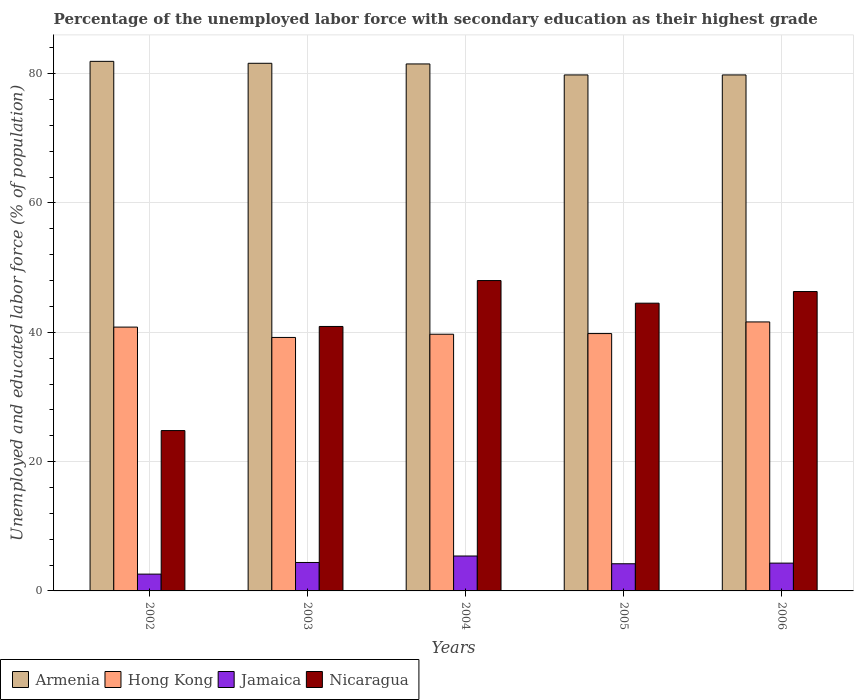Are the number of bars on each tick of the X-axis equal?
Your answer should be compact. Yes. How many bars are there on the 2nd tick from the right?
Provide a succinct answer. 4. What is the label of the 3rd group of bars from the left?
Keep it short and to the point. 2004. In how many cases, is the number of bars for a given year not equal to the number of legend labels?
Your answer should be very brief. 0. What is the percentage of the unemployed labor force with secondary education in Jamaica in 2006?
Your response must be concise. 4.3. Across all years, what is the minimum percentage of the unemployed labor force with secondary education in Hong Kong?
Your answer should be very brief. 39.2. In which year was the percentage of the unemployed labor force with secondary education in Armenia minimum?
Provide a succinct answer. 2005. What is the total percentage of the unemployed labor force with secondary education in Jamaica in the graph?
Make the answer very short. 20.9. What is the difference between the percentage of the unemployed labor force with secondary education in Hong Kong in 2003 and that in 2006?
Make the answer very short. -2.4. What is the difference between the percentage of the unemployed labor force with secondary education in Hong Kong in 2003 and the percentage of the unemployed labor force with secondary education in Armenia in 2004?
Provide a succinct answer. -42.3. What is the average percentage of the unemployed labor force with secondary education in Armenia per year?
Your answer should be very brief. 80.92. In the year 2006, what is the difference between the percentage of the unemployed labor force with secondary education in Armenia and percentage of the unemployed labor force with secondary education in Hong Kong?
Your answer should be compact. 38.2. What is the ratio of the percentage of the unemployed labor force with secondary education in Hong Kong in 2002 to that in 2006?
Give a very brief answer. 0.98. Is the difference between the percentage of the unemployed labor force with secondary education in Armenia in 2004 and 2005 greater than the difference between the percentage of the unemployed labor force with secondary education in Hong Kong in 2004 and 2005?
Offer a terse response. Yes. What is the difference between the highest and the second highest percentage of the unemployed labor force with secondary education in Nicaragua?
Keep it short and to the point. 1.7. What is the difference between the highest and the lowest percentage of the unemployed labor force with secondary education in Hong Kong?
Your answer should be very brief. 2.4. In how many years, is the percentage of the unemployed labor force with secondary education in Armenia greater than the average percentage of the unemployed labor force with secondary education in Armenia taken over all years?
Ensure brevity in your answer.  3. Is the sum of the percentage of the unemployed labor force with secondary education in Armenia in 2002 and 2004 greater than the maximum percentage of the unemployed labor force with secondary education in Hong Kong across all years?
Make the answer very short. Yes. What does the 1st bar from the left in 2003 represents?
Provide a short and direct response. Armenia. What does the 3rd bar from the right in 2002 represents?
Keep it short and to the point. Hong Kong. Is it the case that in every year, the sum of the percentage of the unemployed labor force with secondary education in Armenia and percentage of the unemployed labor force with secondary education in Jamaica is greater than the percentage of the unemployed labor force with secondary education in Hong Kong?
Offer a terse response. Yes. How many bars are there?
Offer a very short reply. 20. How many years are there in the graph?
Give a very brief answer. 5. What is the difference between two consecutive major ticks on the Y-axis?
Offer a very short reply. 20. Does the graph contain any zero values?
Make the answer very short. No. Does the graph contain grids?
Give a very brief answer. Yes. What is the title of the graph?
Provide a succinct answer. Percentage of the unemployed labor force with secondary education as their highest grade. What is the label or title of the X-axis?
Provide a short and direct response. Years. What is the label or title of the Y-axis?
Offer a terse response. Unemployed and educated labor force (% of population). What is the Unemployed and educated labor force (% of population) of Armenia in 2002?
Your response must be concise. 81.9. What is the Unemployed and educated labor force (% of population) in Hong Kong in 2002?
Provide a short and direct response. 40.8. What is the Unemployed and educated labor force (% of population) of Jamaica in 2002?
Your answer should be compact. 2.6. What is the Unemployed and educated labor force (% of population) in Nicaragua in 2002?
Provide a succinct answer. 24.8. What is the Unemployed and educated labor force (% of population) of Armenia in 2003?
Offer a very short reply. 81.6. What is the Unemployed and educated labor force (% of population) of Hong Kong in 2003?
Provide a succinct answer. 39.2. What is the Unemployed and educated labor force (% of population) in Jamaica in 2003?
Offer a very short reply. 4.4. What is the Unemployed and educated labor force (% of population) in Nicaragua in 2003?
Keep it short and to the point. 40.9. What is the Unemployed and educated labor force (% of population) in Armenia in 2004?
Keep it short and to the point. 81.5. What is the Unemployed and educated labor force (% of population) in Hong Kong in 2004?
Provide a short and direct response. 39.7. What is the Unemployed and educated labor force (% of population) of Jamaica in 2004?
Provide a succinct answer. 5.4. What is the Unemployed and educated labor force (% of population) of Nicaragua in 2004?
Offer a very short reply. 48. What is the Unemployed and educated labor force (% of population) in Armenia in 2005?
Keep it short and to the point. 79.8. What is the Unemployed and educated labor force (% of population) in Hong Kong in 2005?
Ensure brevity in your answer.  39.8. What is the Unemployed and educated labor force (% of population) in Jamaica in 2005?
Your answer should be very brief. 4.2. What is the Unemployed and educated labor force (% of population) of Nicaragua in 2005?
Offer a terse response. 44.5. What is the Unemployed and educated labor force (% of population) in Armenia in 2006?
Make the answer very short. 79.8. What is the Unemployed and educated labor force (% of population) in Hong Kong in 2006?
Ensure brevity in your answer.  41.6. What is the Unemployed and educated labor force (% of population) of Jamaica in 2006?
Give a very brief answer. 4.3. What is the Unemployed and educated labor force (% of population) of Nicaragua in 2006?
Provide a short and direct response. 46.3. Across all years, what is the maximum Unemployed and educated labor force (% of population) of Armenia?
Ensure brevity in your answer.  81.9. Across all years, what is the maximum Unemployed and educated labor force (% of population) in Hong Kong?
Make the answer very short. 41.6. Across all years, what is the maximum Unemployed and educated labor force (% of population) of Jamaica?
Keep it short and to the point. 5.4. Across all years, what is the minimum Unemployed and educated labor force (% of population) in Armenia?
Offer a terse response. 79.8. Across all years, what is the minimum Unemployed and educated labor force (% of population) of Hong Kong?
Offer a very short reply. 39.2. Across all years, what is the minimum Unemployed and educated labor force (% of population) of Jamaica?
Your answer should be very brief. 2.6. Across all years, what is the minimum Unemployed and educated labor force (% of population) in Nicaragua?
Provide a short and direct response. 24.8. What is the total Unemployed and educated labor force (% of population) of Armenia in the graph?
Offer a very short reply. 404.6. What is the total Unemployed and educated labor force (% of population) of Hong Kong in the graph?
Ensure brevity in your answer.  201.1. What is the total Unemployed and educated labor force (% of population) of Jamaica in the graph?
Provide a succinct answer. 20.9. What is the total Unemployed and educated labor force (% of population) in Nicaragua in the graph?
Your response must be concise. 204.5. What is the difference between the Unemployed and educated labor force (% of population) in Armenia in 2002 and that in 2003?
Offer a very short reply. 0.3. What is the difference between the Unemployed and educated labor force (% of population) of Nicaragua in 2002 and that in 2003?
Make the answer very short. -16.1. What is the difference between the Unemployed and educated labor force (% of population) of Jamaica in 2002 and that in 2004?
Offer a very short reply. -2.8. What is the difference between the Unemployed and educated labor force (% of population) of Nicaragua in 2002 and that in 2004?
Keep it short and to the point. -23.2. What is the difference between the Unemployed and educated labor force (% of population) of Armenia in 2002 and that in 2005?
Your answer should be very brief. 2.1. What is the difference between the Unemployed and educated labor force (% of population) in Hong Kong in 2002 and that in 2005?
Your response must be concise. 1. What is the difference between the Unemployed and educated labor force (% of population) in Nicaragua in 2002 and that in 2005?
Provide a short and direct response. -19.7. What is the difference between the Unemployed and educated labor force (% of population) in Hong Kong in 2002 and that in 2006?
Provide a succinct answer. -0.8. What is the difference between the Unemployed and educated labor force (% of population) of Nicaragua in 2002 and that in 2006?
Provide a succinct answer. -21.5. What is the difference between the Unemployed and educated labor force (% of population) of Hong Kong in 2003 and that in 2004?
Keep it short and to the point. -0.5. What is the difference between the Unemployed and educated labor force (% of population) in Nicaragua in 2003 and that in 2004?
Make the answer very short. -7.1. What is the difference between the Unemployed and educated labor force (% of population) of Armenia in 2003 and that in 2005?
Give a very brief answer. 1.8. What is the difference between the Unemployed and educated labor force (% of population) in Hong Kong in 2003 and that in 2005?
Offer a very short reply. -0.6. What is the difference between the Unemployed and educated labor force (% of population) in Jamaica in 2003 and that in 2005?
Make the answer very short. 0.2. What is the difference between the Unemployed and educated labor force (% of population) of Nicaragua in 2003 and that in 2005?
Ensure brevity in your answer.  -3.6. What is the difference between the Unemployed and educated labor force (% of population) in Armenia in 2003 and that in 2006?
Your answer should be compact. 1.8. What is the difference between the Unemployed and educated labor force (% of population) in Jamaica in 2003 and that in 2006?
Make the answer very short. 0.1. What is the difference between the Unemployed and educated labor force (% of population) in Nicaragua in 2003 and that in 2006?
Provide a succinct answer. -5.4. What is the difference between the Unemployed and educated labor force (% of population) of Armenia in 2004 and that in 2005?
Keep it short and to the point. 1.7. What is the difference between the Unemployed and educated labor force (% of population) of Jamaica in 2004 and that in 2005?
Your answer should be very brief. 1.2. What is the difference between the Unemployed and educated labor force (% of population) in Nicaragua in 2004 and that in 2005?
Give a very brief answer. 3.5. What is the difference between the Unemployed and educated labor force (% of population) in Hong Kong in 2004 and that in 2006?
Your response must be concise. -1.9. What is the difference between the Unemployed and educated labor force (% of population) in Armenia in 2005 and that in 2006?
Your answer should be compact. 0. What is the difference between the Unemployed and educated labor force (% of population) of Hong Kong in 2005 and that in 2006?
Offer a very short reply. -1.8. What is the difference between the Unemployed and educated labor force (% of population) in Jamaica in 2005 and that in 2006?
Provide a succinct answer. -0.1. What is the difference between the Unemployed and educated labor force (% of population) of Armenia in 2002 and the Unemployed and educated labor force (% of population) of Hong Kong in 2003?
Your answer should be compact. 42.7. What is the difference between the Unemployed and educated labor force (% of population) of Armenia in 2002 and the Unemployed and educated labor force (% of population) of Jamaica in 2003?
Keep it short and to the point. 77.5. What is the difference between the Unemployed and educated labor force (% of population) in Armenia in 2002 and the Unemployed and educated labor force (% of population) in Nicaragua in 2003?
Provide a succinct answer. 41. What is the difference between the Unemployed and educated labor force (% of population) of Hong Kong in 2002 and the Unemployed and educated labor force (% of population) of Jamaica in 2003?
Provide a succinct answer. 36.4. What is the difference between the Unemployed and educated labor force (% of population) of Hong Kong in 2002 and the Unemployed and educated labor force (% of population) of Nicaragua in 2003?
Your answer should be compact. -0.1. What is the difference between the Unemployed and educated labor force (% of population) of Jamaica in 2002 and the Unemployed and educated labor force (% of population) of Nicaragua in 2003?
Keep it short and to the point. -38.3. What is the difference between the Unemployed and educated labor force (% of population) of Armenia in 2002 and the Unemployed and educated labor force (% of population) of Hong Kong in 2004?
Provide a short and direct response. 42.2. What is the difference between the Unemployed and educated labor force (% of population) of Armenia in 2002 and the Unemployed and educated labor force (% of population) of Jamaica in 2004?
Provide a short and direct response. 76.5. What is the difference between the Unemployed and educated labor force (% of population) of Armenia in 2002 and the Unemployed and educated labor force (% of population) of Nicaragua in 2004?
Your response must be concise. 33.9. What is the difference between the Unemployed and educated labor force (% of population) in Hong Kong in 2002 and the Unemployed and educated labor force (% of population) in Jamaica in 2004?
Your answer should be very brief. 35.4. What is the difference between the Unemployed and educated labor force (% of population) of Hong Kong in 2002 and the Unemployed and educated labor force (% of population) of Nicaragua in 2004?
Your answer should be compact. -7.2. What is the difference between the Unemployed and educated labor force (% of population) in Jamaica in 2002 and the Unemployed and educated labor force (% of population) in Nicaragua in 2004?
Your response must be concise. -45.4. What is the difference between the Unemployed and educated labor force (% of population) in Armenia in 2002 and the Unemployed and educated labor force (% of population) in Hong Kong in 2005?
Ensure brevity in your answer.  42.1. What is the difference between the Unemployed and educated labor force (% of population) in Armenia in 2002 and the Unemployed and educated labor force (% of population) in Jamaica in 2005?
Make the answer very short. 77.7. What is the difference between the Unemployed and educated labor force (% of population) of Armenia in 2002 and the Unemployed and educated labor force (% of population) of Nicaragua in 2005?
Ensure brevity in your answer.  37.4. What is the difference between the Unemployed and educated labor force (% of population) in Hong Kong in 2002 and the Unemployed and educated labor force (% of population) in Jamaica in 2005?
Your response must be concise. 36.6. What is the difference between the Unemployed and educated labor force (% of population) in Hong Kong in 2002 and the Unemployed and educated labor force (% of population) in Nicaragua in 2005?
Offer a very short reply. -3.7. What is the difference between the Unemployed and educated labor force (% of population) in Jamaica in 2002 and the Unemployed and educated labor force (% of population) in Nicaragua in 2005?
Provide a succinct answer. -41.9. What is the difference between the Unemployed and educated labor force (% of population) in Armenia in 2002 and the Unemployed and educated labor force (% of population) in Hong Kong in 2006?
Ensure brevity in your answer.  40.3. What is the difference between the Unemployed and educated labor force (% of population) in Armenia in 2002 and the Unemployed and educated labor force (% of population) in Jamaica in 2006?
Provide a succinct answer. 77.6. What is the difference between the Unemployed and educated labor force (% of population) in Armenia in 2002 and the Unemployed and educated labor force (% of population) in Nicaragua in 2006?
Give a very brief answer. 35.6. What is the difference between the Unemployed and educated labor force (% of population) of Hong Kong in 2002 and the Unemployed and educated labor force (% of population) of Jamaica in 2006?
Your answer should be very brief. 36.5. What is the difference between the Unemployed and educated labor force (% of population) in Hong Kong in 2002 and the Unemployed and educated labor force (% of population) in Nicaragua in 2006?
Your answer should be very brief. -5.5. What is the difference between the Unemployed and educated labor force (% of population) in Jamaica in 2002 and the Unemployed and educated labor force (% of population) in Nicaragua in 2006?
Your answer should be compact. -43.7. What is the difference between the Unemployed and educated labor force (% of population) in Armenia in 2003 and the Unemployed and educated labor force (% of population) in Hong Kong in 2004?
Ensure brevity in your answer.  41.9. What is the difference between the Unemployed and educated labor force (% of population) of Armenia in 2003 and the Unemployed and educated labor force (% of population) of Jamaica in 2004?
Ensure brevity in your answer.  76.2. What is the difference between the Unemployed and educated labor force (% of population) in Armenia in 2003 and the Unemployed and educated labor force (% of population) in Nicaragua in 2004?
Offer a terse response. 33.6. What is the difference between the Unemployed and educated labor force (% of population) of Hong Kong in 2003 and the Unemployed and educated labor force (% of population) of Jamaica in 2004?
Your answer should be compact. 33.8. What is the difference between the Unemployed and educated labor force (% of population) of Hong Kong in 2003 and the Unemployed and educated labor force (% of population) of Nicaragua in 2004?
Offer a very short reply. -8.8. What is the difference between the Unemployed and educated labor force (% of population) in Jamaica in 2003 and the Unemployed and educated labor force (% of population) in Nicaragua in 2004?
Make the answer very short. -43.6. What is the difference between the Unemployed and educated labor force (% of population) of Armenia in 2003 and the Unemployed and educated labor force (% of population) of Hong Kong in 2005?
Offer a terse response. 41.8. What is the difference between the Unemployed and educated labor force (% of population) of Armenia in 2003 and the Unemployed and educated labor force (% of population) of Jamaica in 2005?
Give a very brief answer. 77.4. What is the difference between the Unemployed and educated labor force (% of population) of Armenia in 2003 and the Unemployed and educated labor force (% of population) of Nicaragua in 2005?
Keep it short and to the point. 37.1. What is the difference between the Unemployed and educated labor force (% of population) in Hong Kong in 2003 and the Unemployed and educated labor force (% of population) in Nicaragua in 2005?
Offer a terse response. -5.3. What is the difference between the Unemployed and educated labor force (% of population) in Jamaica in 2003 and the Unemployed and educated labor force (% of population) in Nicaragua in 2005?
Your response must be concise. -40.1. What is the difference between the Unemployed and educated labor force (% of population) in Armenia in 2003 and the Unemployed and educated labor force (% of population) in Jamaica in 2006?
Provide a short and direct response. 77.3. What is the difference between the Unemployed and educated labor force (% of population) in Armenia in 2003 and the Unemployed and educated labor force (% of population) in Nicaragua in 2006?
Your answer should be very brief. 35.3. What is the difference between the Unemployed and educated labor force (% of population) of Hong Kong in 2003 and the Unemployed and educated labor force (% of population) of Jamaica in 2006?
Keep it short and to the point. 34.9. What is the difference between the Unemployed and educated labor force (% of population) in Jamaica in 2003 and the Unemployed and educated labor force (% of population) in Nicaragua in 2006?
Your answer should be compact. -41.9. What is the difference between the Unemployed and educated labor force (% of population) of Armenia in 2004 and the Unemployed and educated labor force (% of population) of Hong Kong in 2005?
Provide a succinct answer. 41.7. What is the difference between the Unemployed and educated labor force (% of population) in Armenia in 2004 and the Unemployed and educated labor force (% of population) in Jamaica in 2005?
Offer a very short reply. 77.3. What is the difference between the Unemployed and educated labor force (% of population) of Hong Kong in 2004 and the Unemployed and educated labor force (% of population) of Jamaica in 2005?
Your answer should be compact. 35.5. What is the difference between the Unemployed and educated labor force (% of population) in Jamaica in 2004 and the Unemployed and educated labor force (% of population) in Nicaragua in 2005?
Your answer should be very brief. -39.1. What is the difference between the Unemployed and educated labor force (% of population) of Armenia in 2004 and the Unemployed and educated labor force (% of population) of Hong Kong in 2006?
Provide a succinct answer. 39.9. What is the difference between the Unemployed and educated labor force (% of population) of Armenia in 2004 and the Unemployed and educated labor force (% of population) of Jamaica in 2006?
Your response must be concise. 77.2. What is the difference between the Unemployed and educated labor force (% of population) in Armenia in 2004 and the Unemployed and educated labor force (% of population) in Nicaragua in 2006?
Offer a terse response. 35.2. What is the difference between the Unemployed and educated labor force (% of population) of Hong Kong in 2004 and the Unemployed and educated labor force (% of population) of Jamaica in 2006?
Ensure brevity in your answer.  35.4. What is the difference between the Unemployed and educated labor force (% of population) of Hong Kong in 2004 and the Unemployed and educated labor force (% of population) of Nicaragua in 2006?
Your answer should be very brief. -6.6. What is the difference between the Unemployed and educated labor force (% of population) of Jamaica in 2004 and the Unemployed and educated labor force (% of population) of Nicaragua in 2006?
Offer a terse response. -40.9. What is the difference between the Unemployed and educated labor force (% of population) in Armenia in 2005 and the Unemployed and educated labor force (% of population) in Hong Kong in 2006?
Provide a succinct answer. 38.2. What is the difference between the Unemployed and educated labor force (% of population) of Armenia in 2005 and the Unemployed and educated labor force (% of population) of Jamaica in 2006?
Make the answer very short. 75.5. What is the difference between the Unemployed and educated labor force (% of population) in Armenia in 2005 and the Unemployed and educated labor force (% of population) in Nicaragua in 2006?
Offer a terse response. 33.5. What is the difference between the Unemployed and educated labor force (% of population) in Hong Kong in 2005 and the Unemployed and educated labor force (% of population) in Jamaica in 2006?
Provide a short and direct response. 35.5. What is the difference between the Unemployed and educated labor force (% of population) of Hong Kong in 2005 and the Unemployed and educated labor force (% of population) of Nicaragua in 2006?
Provide a succinct answer. -6.5. What is the difference between the Unemployed and educated labor force (% of population) of Jamaica in 2005 and the Unemployed and educated labor force (% of population) of Nicaragua in 2006?
Ensure brevity in your answer.  -42.1. What is the average Unemployed and educated labor force (% of population) of Armenia per year?
Provide a succinct answer. 80.92. What is the average Unemployed and educated labor force (% of population) of Hong Kong per year?
Provide a succinct answer. 40.22. What is the average Unemployed and educated labor force (% of population) of Jamaica per year?
Your answer should be compact. 4.18. What is the average Unemployed and educated labor force (% of population) of Nicaragua per year?
Ensure brevity in your answer.  40.9. In the year 2002, what is the difference between the Unemployed and educated labor force (% of population) of Armenia and Unemployed and educated labor force (% of population) of Hong Kong?
Provide a succinct answer. 41.1. In the year 2002, what is the difference between the Unemployed and educated labor force (% of population) of Armenia and Unemployed and educated labor force (% of population) of Jamaica?
Your response must be concise. 79.3. In the year 2002, what is the difference between the Unemployed and educated labor force (% of population) of Armenia and Unemployed and educated labor force (% of population) of Nicaragua?
Your answer should be very brief. 57.1. In the year 2002, what is the difference between the Unemployed and educated labor force (% of population) in Hong Kong and Unemployed and educated labor force (% of population) in Jamaica?
Offer a very short reply. 38.2. In the year 2002, what is the difference between the Unemployed and educated labor force (% of population) in Jamaica and Unemployed and educated labor force (% of population) in Nicaragua?
Give a very brief answer. -22.2. In the year 2003, what is the difference between the Unemployed and educated labor force (% of population) of Armenia and Unemployed and educated labor force (% of population) of Hong Kong?
Provide a succinct answer. 42.4. In the year 2003, what is the difference between the Unemployed and educated labor force (% of population) in Armenia and Unemployed and educated labor force (% of population) in Jamaica?
Your answer should be very brief. 77.2. In the year 2003, what is the difference between the Unemployed and educated labor force (% of population) of Armenia and Unemployed and educated labor force (% of population) of Nicaragua?
Your response must be concise. 40.7. In the year 2003, what is the difference between the Unemployed and educated labor force (% of population) of Hong Kong and Unemployed and educated labor force (% of population) of Jamaica?
Provide a succinct answer. 34.8. In the year 2003, what is the difference between the Unemployed and educated labor force (% of population) in Hong Kong and Unemployed and educated labor force (% of population) in Nicaragua?
Your answer should be very brief. -1.7. In the year 2003, what is the difference between the Unemployed and educated labor force (% of population) of Jamaica and Unemployed and educated labor force (% of population) of Nicaragua?
Make the answer very short. -36.5. In the year 2004, what is the difference between the Unemployed and educated labor force (% of population) in Armenia and Unemployed and educated labor force (% of population) in Hong Kong?
Your answer should be very brief. 41.8. In the year 2004, what is the difference between the Unemployed and educated labor force (% of population) in Armenia and Unemployed and educated labor force (% of population) in Jamaica?
Provide a short and direct response. 76.1. In the year 2004, what is the difference between the Unemployed and educated labor force (% of population) of Armenia and Unemployed and educated labor force (% of population) of Nicaragua?
Provide a succinct answer. 33.5. In the year 2004, what is the difference between the Unemployed and educated labor force (% of population) of Hong Kong and Unemployed and educated labor force (% of population) of Jamaica?
Offer a terse response. 34.3. In the year 2004, what is the difference between the Unemployed and educated labor force (% of population) in Jamaica and Unemployed and educated labor force (% of population) in Nicaragua?
Your answer should be compact. -42.6. In the year 2005, what is the difference between the Unemployed and educated labor force (% of population) in Armenia and Unemployed and educated labor force (% of population) in Hong Kong?
Give a very brief answer. 40. In the year 2005, what is the difference between the Unemployed and educated labor force (% of population) of Armenia and Unemployed and educated labor force (% of population) of Jamaica?
Your answer should be very brief. 75.6. In the year 2005, what is the difference between the Unemployed and educated labor force (% of population) of Armenia and Unemployed and educated labor force (% of population) of Nicaragua?
Keep it short and to the point. 35.3. In the year 2005, what is the difference between the Unemployed and educated labor force (% of population) of Hong Kong and Unemployed and educated labor force (% of population) of Jamaica?
Provide a short and direct response. 35.6. In the year 2005, what is the difference between the Unemployed and educated labor force (% of population) of Hong Kong and Unemployed and educated labor force (% of population) of Nicaragua?
Offer a very short reply. -4.7. In the year 2005, what is the difference between the Unemployed and educated labor force (% of population) of Jamaica and Unemployed and educated labor force (% of population) of Nicaragua?
Your answer should be very brief. -40.3. In the year 2006, what is the difference between the Unemployed and educated labor force (% of population) of Armenia and Unemployed and educated labor force (% of population) of Hong Kong?
Your answer should be very brief. 38.2. In the year 2006, what is the difference between the Unemployed and educated labor force (% of population) in Armenia and Unemployed and educated labor force (% of population) in Jamaica?
Your response must be concise. 75.5. In the year 2006, what is the difference between the Unemployed and educated labor force (% of population) of Armenia and Unemployed and educated labor force (% of population) of Nicaragua?
Your response must be concise. 33.5. In the year 2006, what is the difference between the Unemployed and educated labor force (% of population) in Hong Kong and Unemployed and educated labor force (% of population) in Jamaica?
Keep it short and to the point. 37.3. In the year 2006, what is the difference between the Unemployed and educated labor force (% of population) in Hong Kong and Unemployed and educated labor force (% of population) in Nicaragua?
Provide a short and direct response. -4.7. In the year 2006, what is the difference between the Unemployed and educated labor force (% of population) of Jamaica and Unemployed and educated labor force (% of population) of Nicaragua?
Give a very brief answer. -42. What is the ratio of the Unemployed and educated labor force (% of population) in Hong Kong in 2002 to that in 2003?
Provide a succinct answer. 1.04. What is the ratio of the Unemployed and educated labor force (% of population) in Jamaica in 2002 to that in 2003?
Your answer should be very brief. 0.59. What is the ratio of the Unemployed and educated labor force (% of population) of Nicaragua in 2002 to that in 2003?
Your answer should be compact. 0.61. What is the ratio of the Unemployed and educated labor force (% of population) in Armenia in 2002 to that in 2004?
Your answer should be compact. 1. What is the ratio of the Unemployed and educated labor force (% of population) of Hong Kong in 2002 to that in 2004?
Provide a succinct answer. 1.03. What is the ratio of the Unemployed and educated labor force (% of population) of Jamaica in 2002 to that in 2004?
Your response must be concise. 0.48. What is the ratio of the Unemployed and educated labor force (% of population) of Nicaragua in 2002 to that in 2004?
Your response must be concise. 0.52. What is the ratio of the Unemployed and educated labor force (% of population) of Armenia in 2002 to that in 2005?
Your answer should be compact. 1.03. What is the ratio of the Unemployed and educated labor force (% of population) of Hong Kong in 2002 to that in 2005?
Offer a terse response. 1.03. What is the ratio of the Unemployed and educated labor force (% of population) in Jamaica in 2002 to that in 2005?
Offer a terse response. 0.62. What is the ratio of the Unemployed and educated labor force (% of population) of Nicaragua in 2002 to that in 2005?
Your response must be concise. 0.56. What is the ratio of the Unemployed and educated labor force (% of population) in Armenia in 2002 to that in 2006?
Make the answer very short. 1.03. What is the ratio of the Unemployed and educated labor force (% of population) of Hong Kong in 2002 to that in 2006?
Offer a very short reply. 0.98. What is the ratio of the Unemployed and educated labor force (% of population) in Jamaica in 2002 to that in 2006?
Provide a short and direct response. 0.6. What is the ratio of the Unemployed and educated labor force (% of population) in Nicaragua in 2002 to that in 2006?
Offer a very short reply. 0.54. What is the ratio of the Unemployed and educated labor force (% of population) in Hong Kong in 2003 to that in 2004?
Keep it short and to the point. 0.99. What is the ratio of the Unemployed and educated labor force (% of population) in Jamaica in 2003 to that in 2004?
Provide a short and direct response. 0.81. What is the ratio of the Unemployed and educated labor force (% of population) of Nicaragua in 2003 to that in 2004?
Offer a terse response. 0.85. What is the ratio of the Unemployed and educated labor force (% of population) in Armenia in 2003 to that in 2005?
Provide a short and direct response. 1.02. What is the ratio of the Unemployed and educated labor force (% of population) of Hong Kong in 2003 to that in 2005?
Offer a very short reply. 0.98. What is the ratio of the Unemployed and educated labor force (% of population) of Jamaica in 2003 to that in 2005?
Your answer should be compact. 1.05. What is the ratio of the Unemployed and educated labor force (% of population) in Nicaragua in 2003 to that in 2005?
Provide a short and direct response. 0.92. What is the ratio of the Unemployed and educated labor force (% of population) in Armenia in 2003 to that in 2006?
Provide a succinct answer. 1.02. What is the ratio of the Unemployed and educated labor force (% of population) in Hong Kong in 2003 to that in 2006?
Give a very brief answer. 0.94. What is the ratio of the Unemployed and educated labor force (% of population) in Jamaica in 2003 to that in 2006?
Your response must be concise. 1.02. What is the ratio of the Unemployed and educated labor force (% of population) of Nicaragua in 2003 to that in 2006?
Provide a succinct answer. 0.88. What is the ratio of the Unemployed and educated labor force (% of population) of Armenia in 2004 to that in 2005?
Keep it short and to the point. 1.02. What is the ratio of the Unemployed and educated labor force (% of population) of Hong Kong in 2004 to that in 2005?
Make the answer very short. 1. What is the ratio of the Unemployed and educated labor force (% of population) of Jamaica in 2004 to that in 2005?
Provide a short and direct response. 1.29. What is the ratio of the Unemployed and educated labor force (% of population) in Nicaragua in 2004 to that in 2005?
Give a very brief answer. 1.08. What is the ratio of the Unemployed and educated labor force (% of population) in Armenia in 2004 to that in 2006?
Provide a short and direct response. 1.02. What is the ratio of the Unemployed and educated labor force (% of population) in Hong Kong in 2004 to that in 2006?
Provide a short and direct response. 0.95. What is the ratio of the Unemployed and educated labor force (% of population) of Jamaica in 2004 to that in 2006?
Your answer should be compact. 1.26. What is the ratio of the Unemployed and educated labor force (% of population) of Nicaragua in 2004 to that in 2006?
Your answer should be very brief. 1.04. What is the ratio of the Unemployed and educated labor force (% of population) in Hong Kong in 2005 to that in 2006?
Offer a very short reply. 0.96. What is the ratio of the Unemployed and educated labor force (% of population) of Jamaica in 2005 to that in 2006?
Offer a very short reply. 0.98. What is the ratio of the Unemployed and educated labor force (% of population) in Nicaragua in 2005 to that in 2006?
Offer a terse response. 0.96. What is the difference between the highest and the second highest Unemployed and educated labor force (% of population) of Armenia?
Your response must be concise. 0.3. What is the difference between the highest and the second highest Unemployed and educated labor force (% of population) in Nicaragua?
Keep it short and to the point. 1.7. What is the difference between the highest and the lowest Unemployed and educated labor force (% of population) of Armenia?
Make the answer very short. 2.1. What is the difference between the highest and the lowest Unemployed and educated labor force (% of population) of Jamaica?
Your response must be concise. 2.8. What is the difference between the highest and the lowest Unemployed and educated labor force (% of population) in Nicaragua?
Make the answer very short. 23.2. 